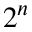<formula> <loc_0><loc_0><loc_500><loc_500>2 ^ { n }</formula> 